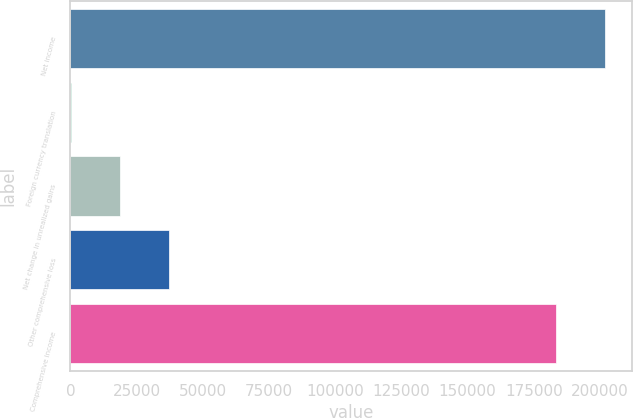Convert chart to OTSL. <chart><loc_0><loc_0><loc_500><loc_500><bar_chart><fcel>Net income<fcel>Foreign currency translation<fcel>Net change in unrealized gains<fcel>Other comprehensive loss<fcel>Comprehensive income<nl><fcel>201773<fcel>348<fcel>18732.1<fcel>37116.2<fcel>183389<nl></chart> 